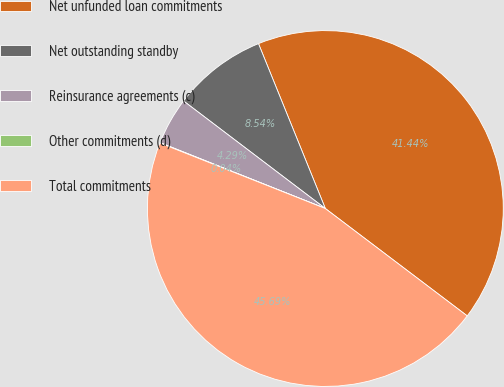Convert chart to OTSL. <chart><loc_0><loc_0><loc_500><loc_500><pie_chart><fcel>Net unfunded loan commitments<fcel>Net outstanding standby<fcel>Reinsurance agreements (c)<fcel>Other commitments (d)<fcel>Total commitments<nl><fcel>41.44%<fcel>8.54%<fcel>4.29%<fcel>0.04%<fcel>45.69%<nl></chart> 